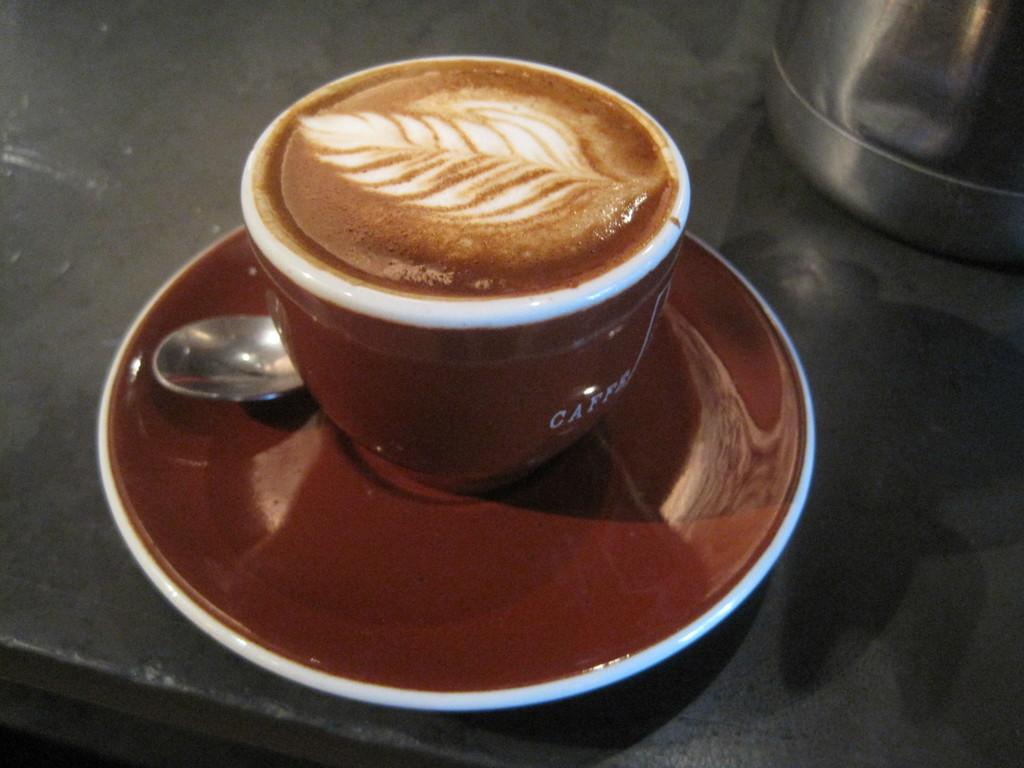What is in the cup that is visible in the image? There is a cup containing cappuccino in the image. What accompanies the cup in the image? A saucer is present in the image. What utensil is visible in the image? A spoon is visible in the image. Where are these objects placed in the image? The objects are placed on a table. What other object can be seen on the table? There is a steel vessel on the table. What type of stitch is used to design the cup in the image? The cup in the image does not have any visible stitching, as it is a solid object. 